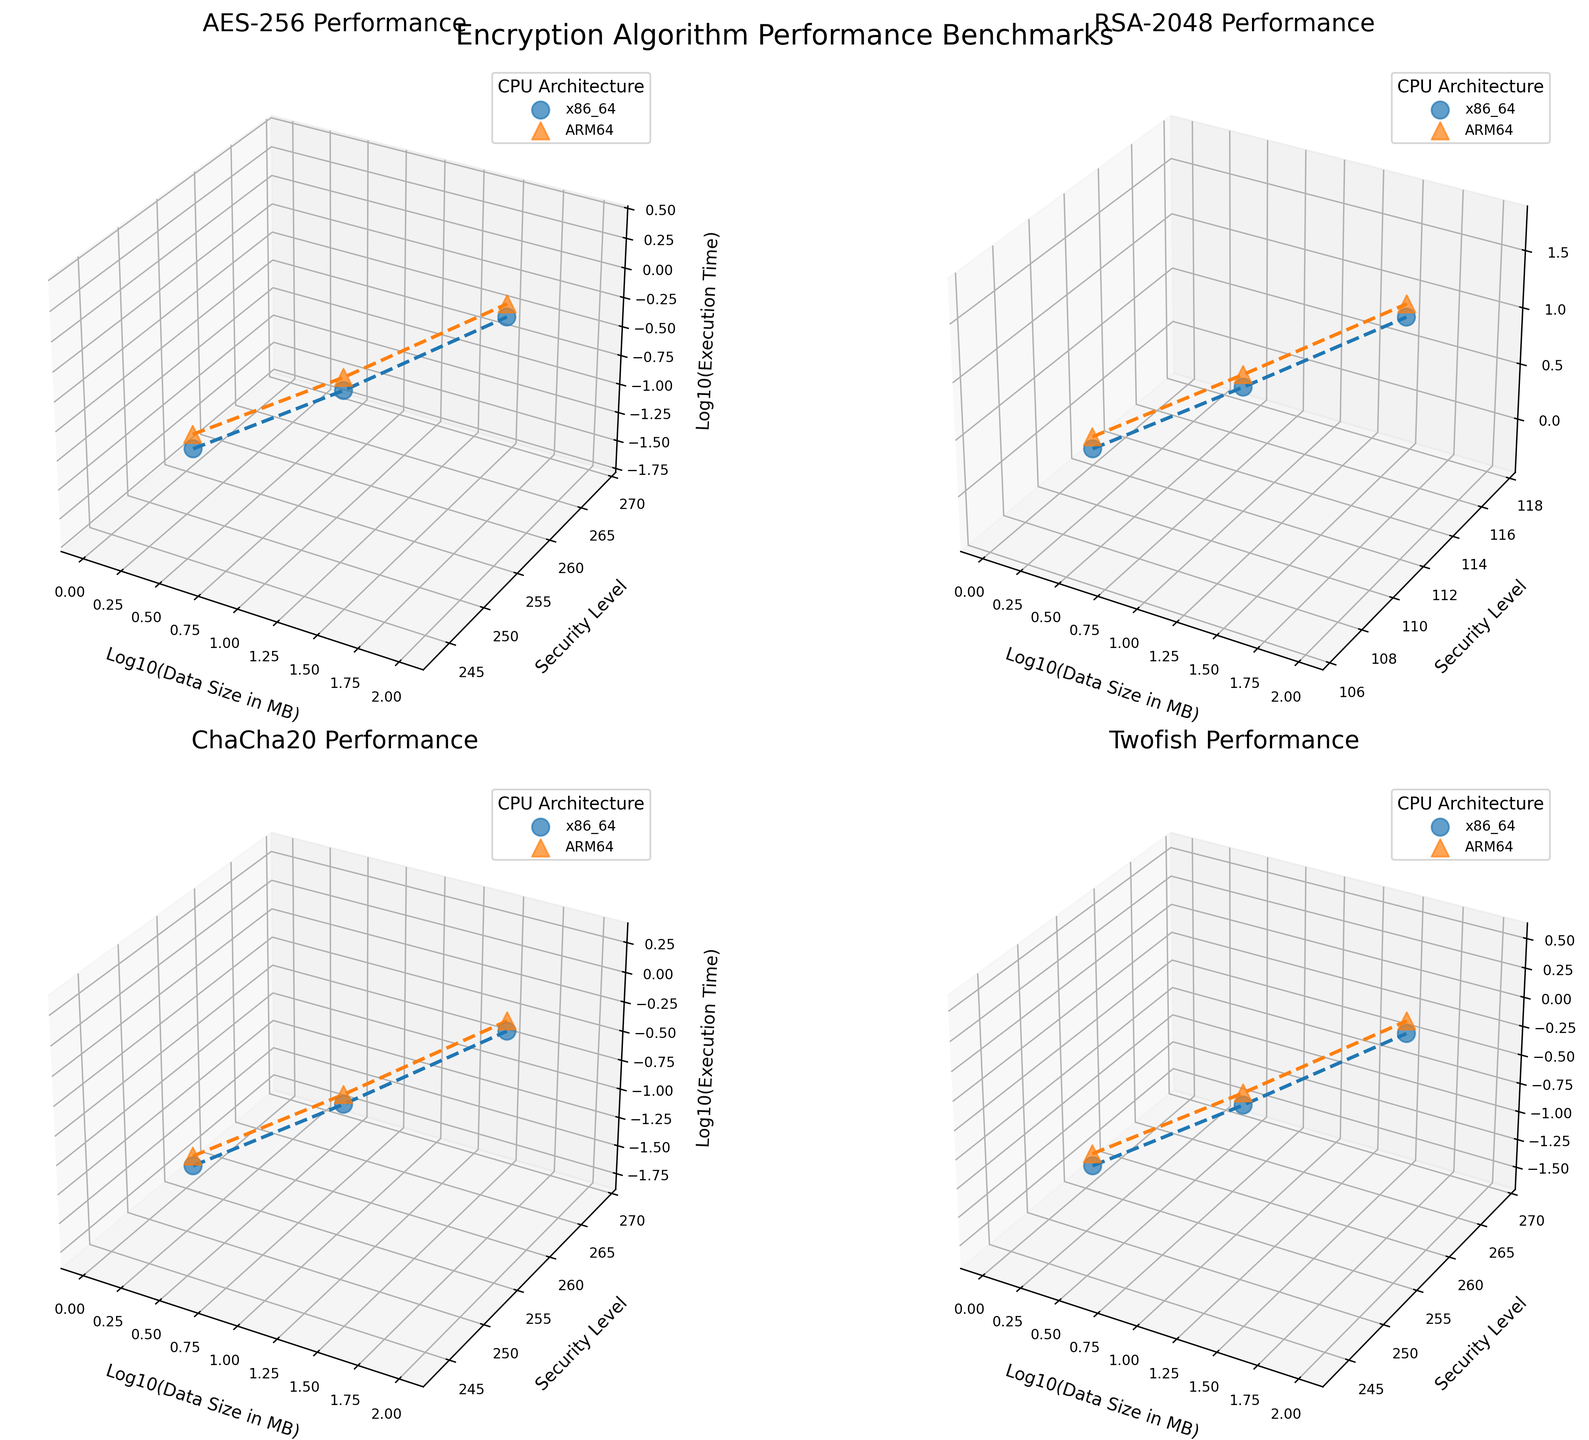What is the title of the entire figure? The title of the figure is located at the top center of the plot and it reads "Encryption Algorithm Performance Benchmarks".
Answer: Encryption Algorithm Performance Benchmarks What does the x-axis represent in these 3D subplots? The x-axis in each 3D subplot represents the logarithm base 10 of the data size in megabytes (MB). This is indicated by the axis label "Log10(Data Size in MB)".
Answer: Log10(Data Size in MB) How does the execution time for AES-256 vary between x86_64 and ARM64 CPUs for 100MB of data? Locate the AES-256 subplot. The markers for x86_64 and ARM64 at 100MB data size have different z-coordinates (execution times). x86_64 shows a lower execution time (around 3) compared to ARM64 (above 3).
Answer: x86_64 has a lower execution time than ARM64 Which algorithm shows the largest difference in execution time between 1MB and 100MB data sizes on the ARM64 architecture? Look at each algorithm across these data sizes on ARM64. The RSA-2048 algorithm has a significant jump in execution time from 0.589 (1MB) to 53.912 (100MB).
Answer: RSA-2048 What is the general trend of execution time with increasing data size for all algorithms? In each subplot, observe how the z-axis (execution time) changes with the x-axis (logarithm of data size). For all algorithms, execution time generally increases as the data size increases.
Answer: Increases with increasing data size Between AES-256 and ChaCha20, which algorithm performs better for 10MB data on the x86_64 architecture? Compare the z-coordinates (execution times) for both algorithms at 10MB on x86_64. ChaCha20 has a significantly lower execution time (around 0.156) compared to AES-256 (around 0.187).
Answer: ChaCha20 Which CPU architecture generally performs better for the Twofish algorithm in terms of execution time at the highest security level? In the Twofish subplot, compare the z-coordinates of markers for highest security level (256) between x86_64 and ARM64 across data sizes. x86_64 consistently has lower execution times.
Answer: x86_64 What is the range of security levels tested in this figure? Inspect the y-axis labels in all subplots. The security levels range from 112 (minimum) to 256 (maximum).
Answer: 112 to 256 Which algorithm has the least variation in execution time across different data sizes on the x86_64 architecture? Examine all subplots and compare the variation of z-coordinates for x86_64 markers. ChaCha20 shows the least variation in execution time across different data sizes.
Answer: ChaCha20 